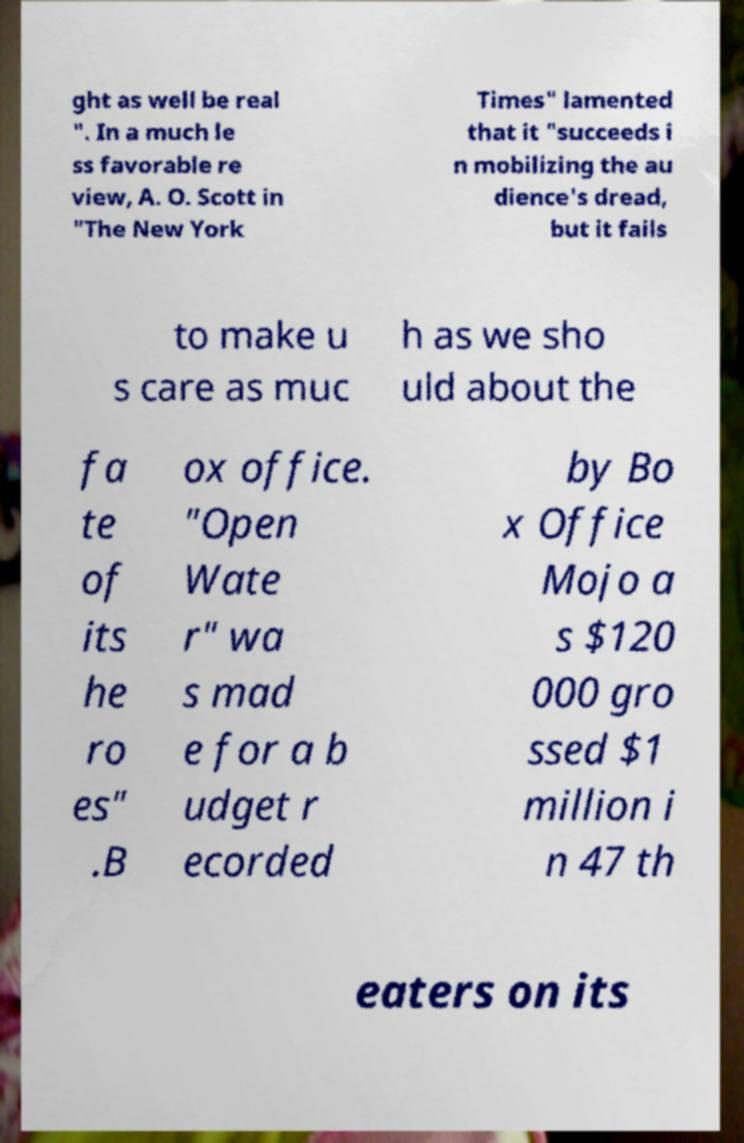For documentation purposes, I need the text within this image transcribed. Could you provide that? ght as well be real ". In a much le ss favorable re view, A. O. Scott in "The New York Times" lamented that it "succeeds i n mobilizing the au dience's dread, but it fails to make u s care as muc h as we sho uld about the fa te of its he ro es" .B ox office. "Open Wate r" wa s mad e for a b udget r ecorded by Bo x Office Mojo a s $120 000 gro ssed $1 million i n 47 th eaters on its 